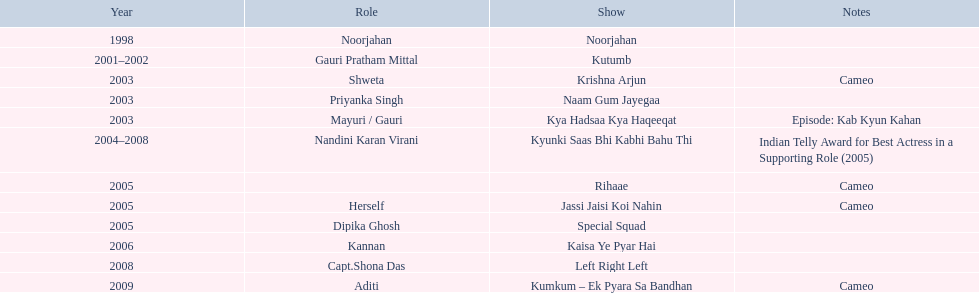What role  was played for the latest show Cameo. Who played the last cameo before ? Jassi Jaisi Koi Nahin. 